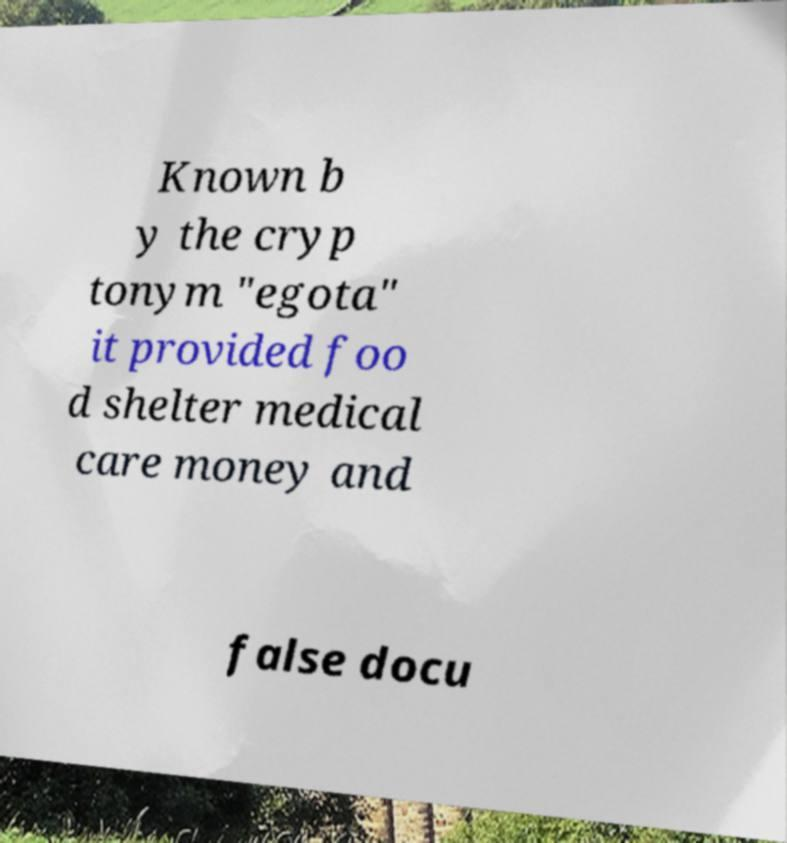Could you extract and type out the text from this image? Known b y the cryp tonym "egota" it provided foo d shelter medical care money and false docu 